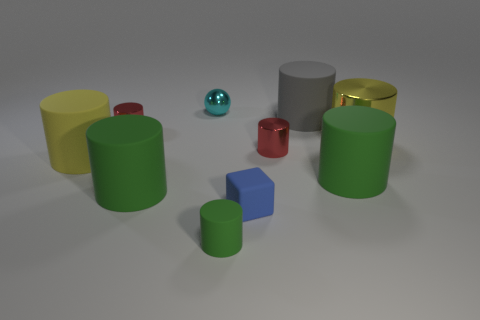Subtract all red cylinders. How many were subtracted if there are1red cylinders left? 1 Subtract all small red cylinders. How many cylinders are left? 6 Subtract all gray cylinders. How many cylinders are left? 7 Subtract all cylinders. How many objects are left? 2 Add 8 tiny green metal balls. How many tiny green metal balls exist? 8 Subtract 0 purple cylinders. How many objects are left? 10 Subtract 1 blocks. How many blocks are left? 0 Subtract all green spheres. Subtract all blue cylinders. How many spheres are left? 1 Subtract all gray blocks. How many green cylinders are left? 3 Subtract all tiny things. Subtract all small cubes. How many objects are left? 4 